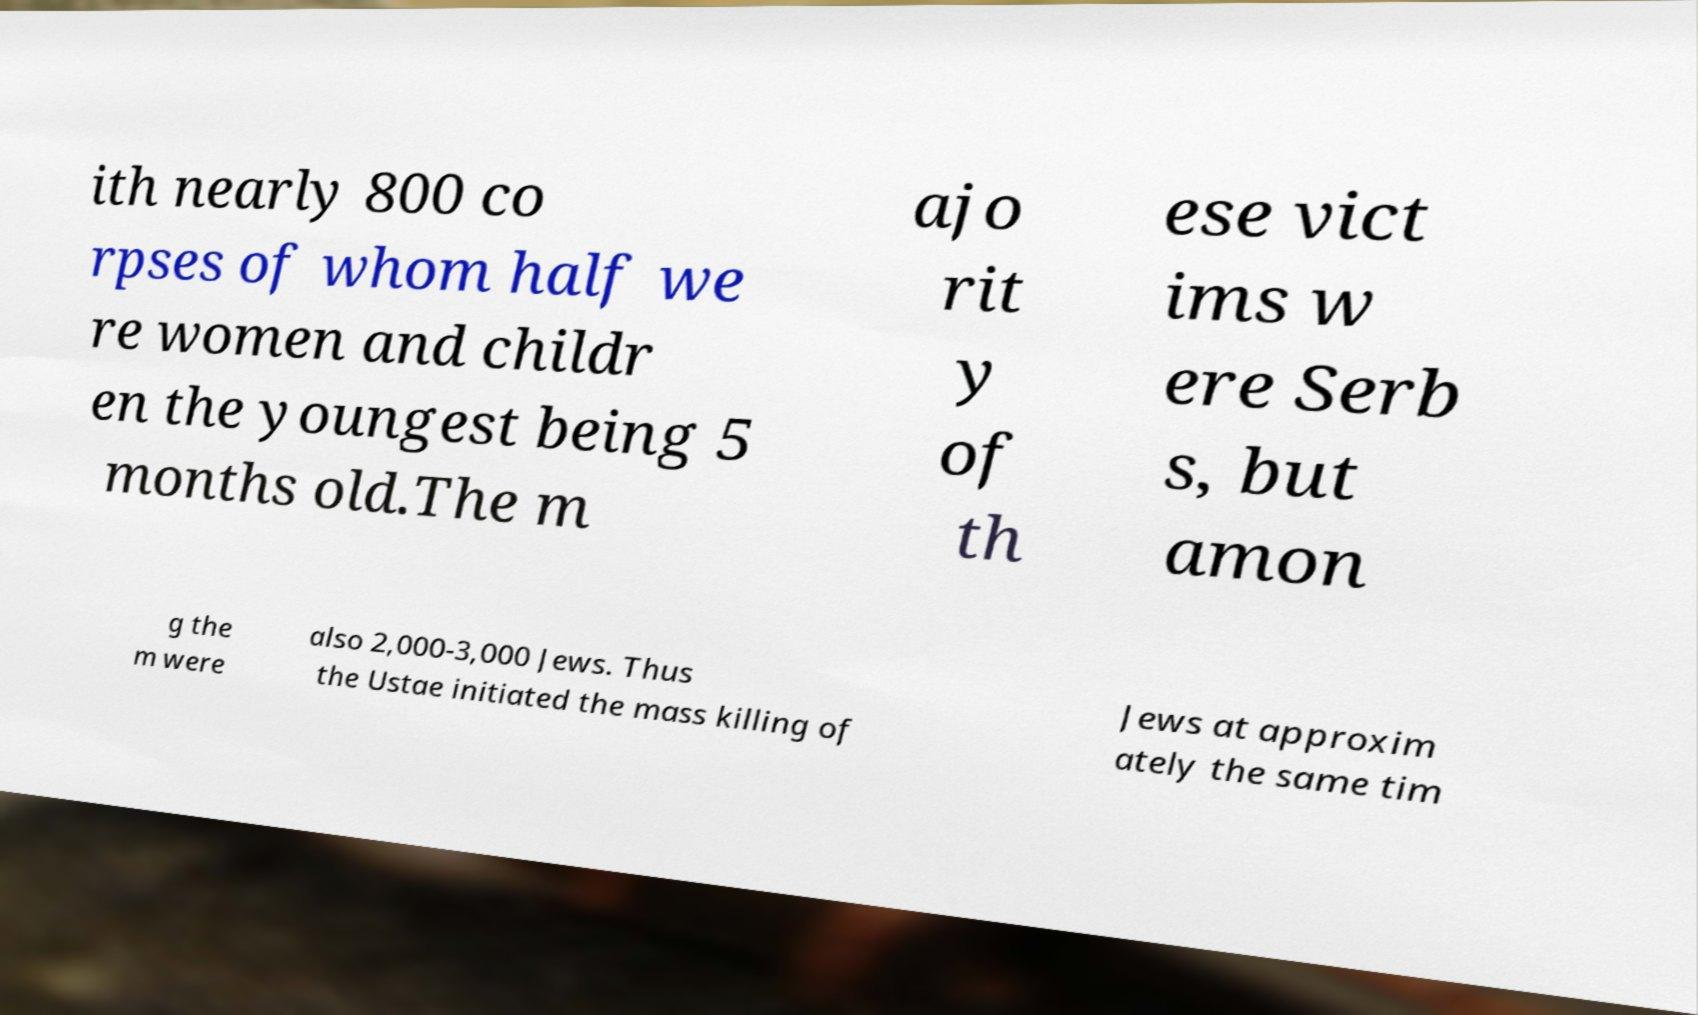I need the written content from this picture converted into text. Can you do that? ith nearly 800 co rpses of whom half we re women and childr en the youngest being 5 months old.The m ajo rit y of th ese vict ims w ere Serb s, but amon g the m were also 2,000-3,000 Jews. Thus the Ustae initiated the mass killing of Jews at approxim ately the same tim 